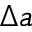<formula> <loc_0><loc_0><loc_500><loc_500>\Delta a</formula> 